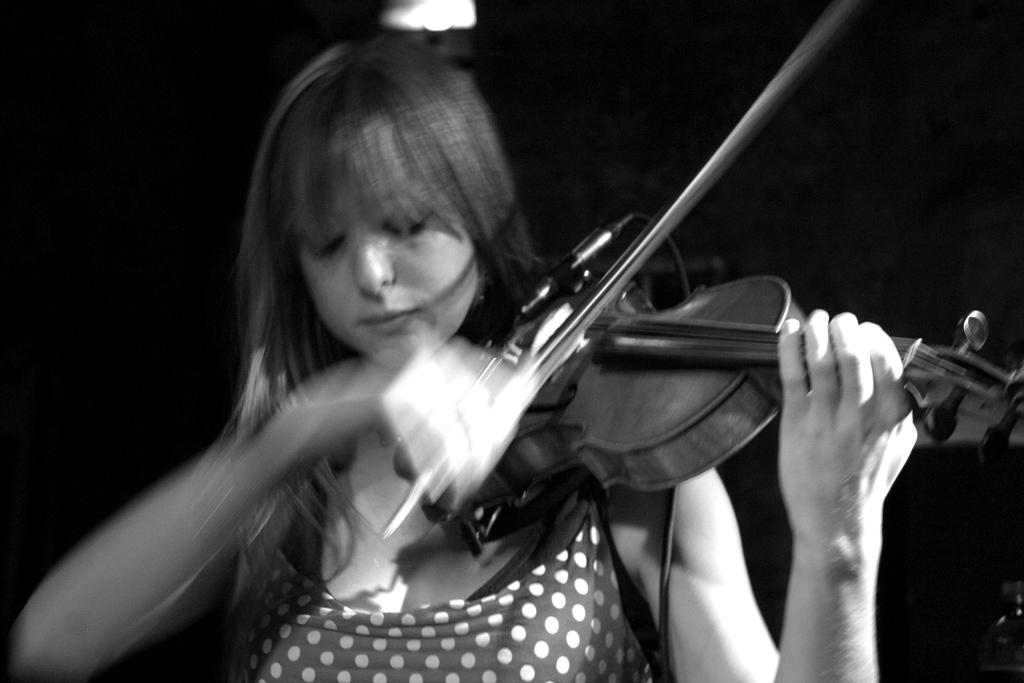What is the woman in the image holding? She is holding a piano. What is she doing with the piano? She is playing the piano. What color is the dress she is wearing? She is wearing a black color dress. What can be seen in the background of the image? There is a black color curtain and lights visible in the background. How many frogs are sitting on the piano in the image? There are no frogs present in the image; the woman is playing the piano alone. 